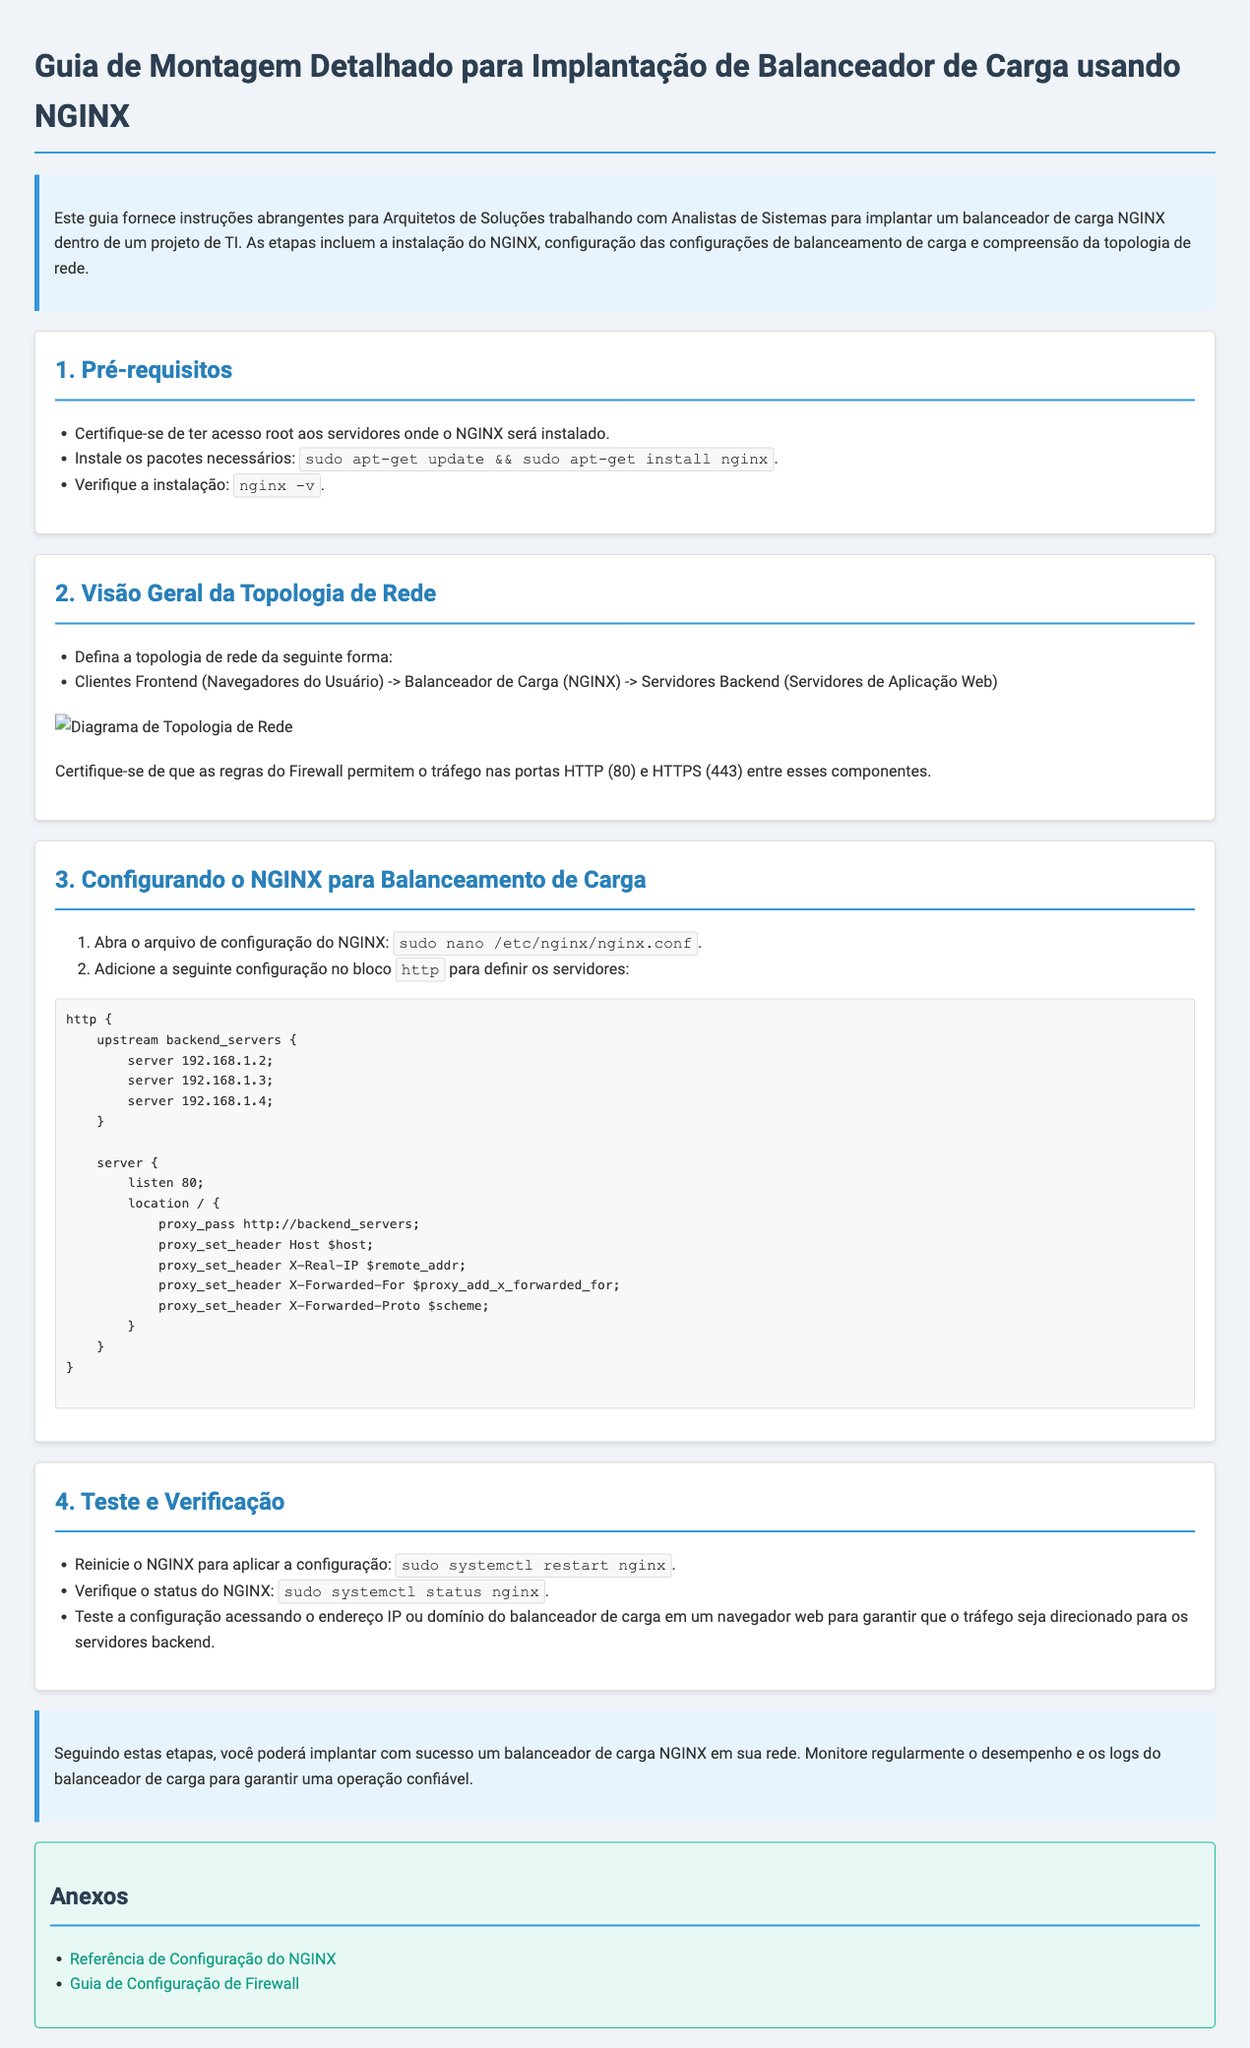qual é o título do documento? O título do documento é apresentado no cabeçalho, descrevendo o propósito principal do guia.
Answer: Guia de Montagem Detalhado para Implantação de Balanceador de Carga usando NGINX quais são os pré-requisitos listados? Os pré-requisitos são informações essenciais que precisam ser atendidas antes de seguir as instruções do guia.
Answer: Acesso root, instalação do NGINX, verificação da instalação quem são os principais colaboradores no projeto? Os principais colaboradores são identificados na introdução do documento, destacando a colaboração necessária para a implementação.
Answer: Arquitetos de Soluções e Analistas de Sistemas qual é o comando para reiniciar o NGINX? O comando fornece uma maneira de aplicar as novas configurações feitas no NGINX, sendo uma ferramenta fundamental nesse processo.
Answer: sudo systemctl restart nginx como a topologia da rede é descrita? A topologia da rede é uma representação visual que ilustra os componentes envolvidos e sua interconexão, conforme mencionado nas instruções.
Answer: Clientes Frontend -> Balanceador de Carga -> Servidores Backend o que deve ser feito para verificar a instalação do NGINX? A verificação da instalação é uma etapa fundamental que confirma se o NGINX foi instalado corretamente no sistema.
Answer: nginx -v qual é a URL para a referência de configuração do NGINX? A URL é um link direto para uma fonte adicional que pode ajudar com configurações específicas do NGINX.
Answer: https://nginx.org/en/docs/ o que deve ser garantido em relação ao firewall? A segurança da rede é mencionada no guia, detalhando as regras necessárias para permitir o tráfego entre componentes.
Answer: Regras do Firewall permitem tráfego nas portas HTTP e HTTPS 